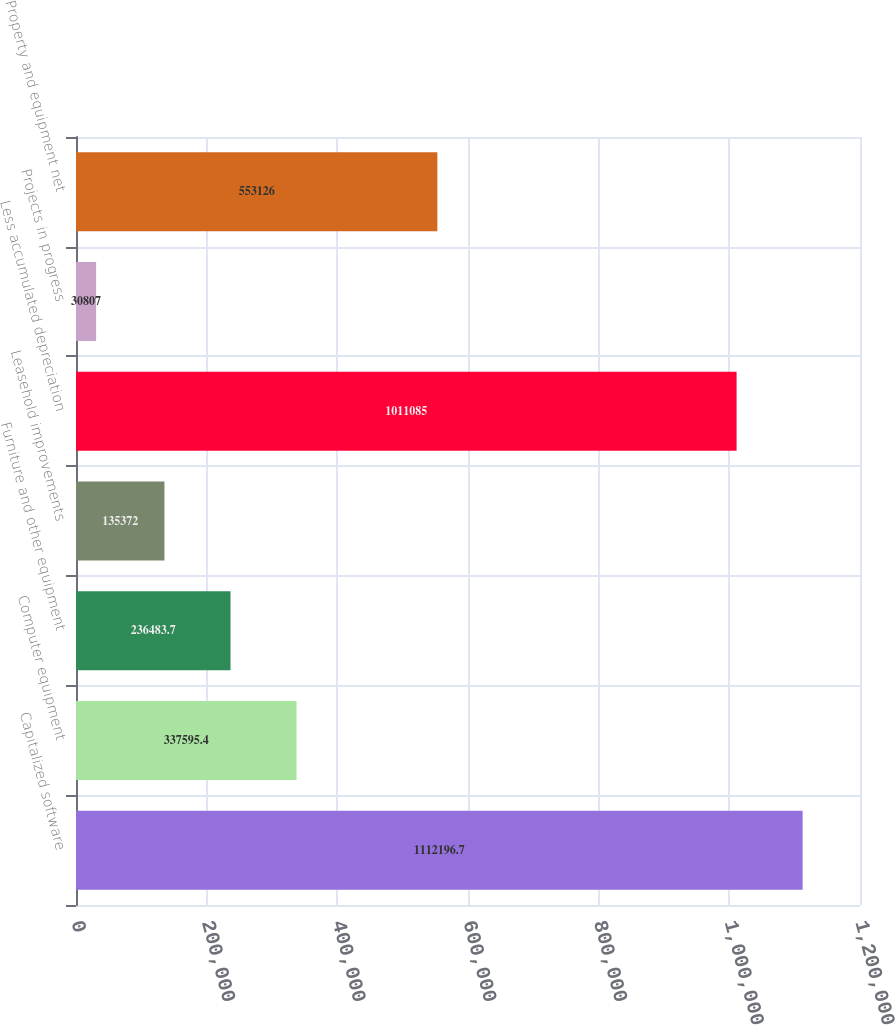Convert chart. <chart><loc_0><loc_0><loc_500><loc_500><bar_chart><fcel>Capitalized software<fcel>Computer equipment<fcel>Furniture and other equipment<fcel>Leasehold improvements<fcel>Less accumulated depreciation<fcel>Projects in progress<fcel>Property and equipment net<nl><fcel>1.1122e+06<fcel>337595<fcel>236484<fcel>135372<fcel>1.01108e+06<fcel>30807<fcel>553126<nl></chart> 